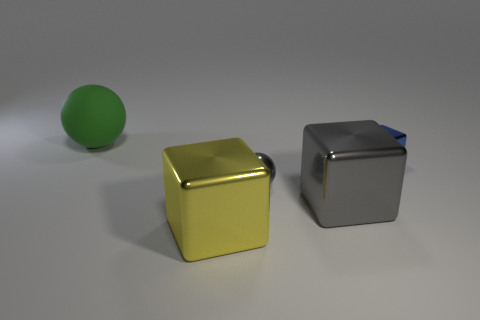The tiny object in front of the tiny thing that is to the right of the big block right of the yellow object is made of what material?
Ensure brevity in your answer.  Metal. Do the ball that is behind the tiny cube and the large gray cube have the same material?
Keep it short and to the point. No. How many other rubber objects have the same size as the green matte thing?
Your answer should be compact. 0. Are there more objects that are on the right side of the big green matte ball than big yellow metallic cubes to the right of the metallic ball?
Keep it short and to the point. Yes. Is there a gray metallic object that has the same shape as the green rubber object?
Your answer should be very brief. Yes. How big is the rubber ball behind the ball in front of the rubber sphere?
Your answer should be very brief. Large. The large object on the left side of the big metallic thing that is to the left of the tiny gray metallic thing on the left side of the tiny blue thing is what shape?
Keep it short and to the point. Sphere. There is a blue block that is made of the same material as the tiny gray thing; what size is it?
Provide a succinct answer. Small. Is the number of red metal things greater than the number of yellow objects?
Keep it short and to the point. No. There is a gray cube that is the same size as the green matte thing; what is it made of?
Your answer should be compact. Metal. 